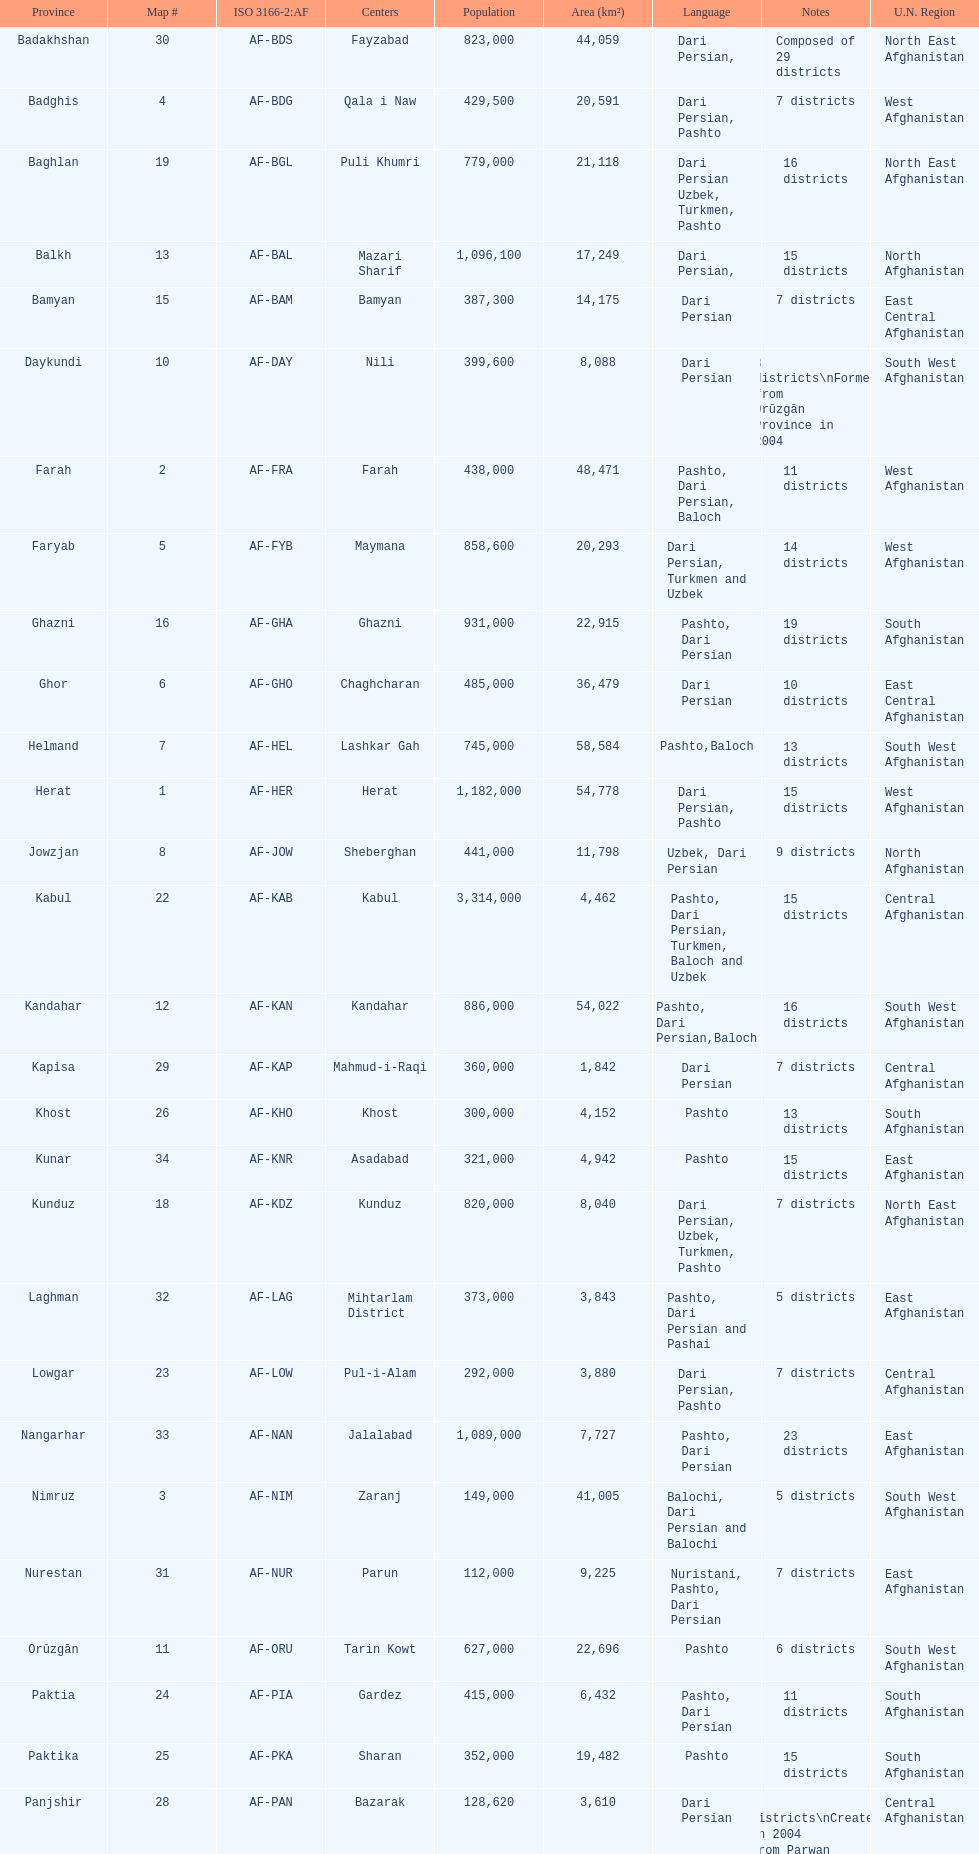What province in afghanistanhas the greatest population? Kabul. 